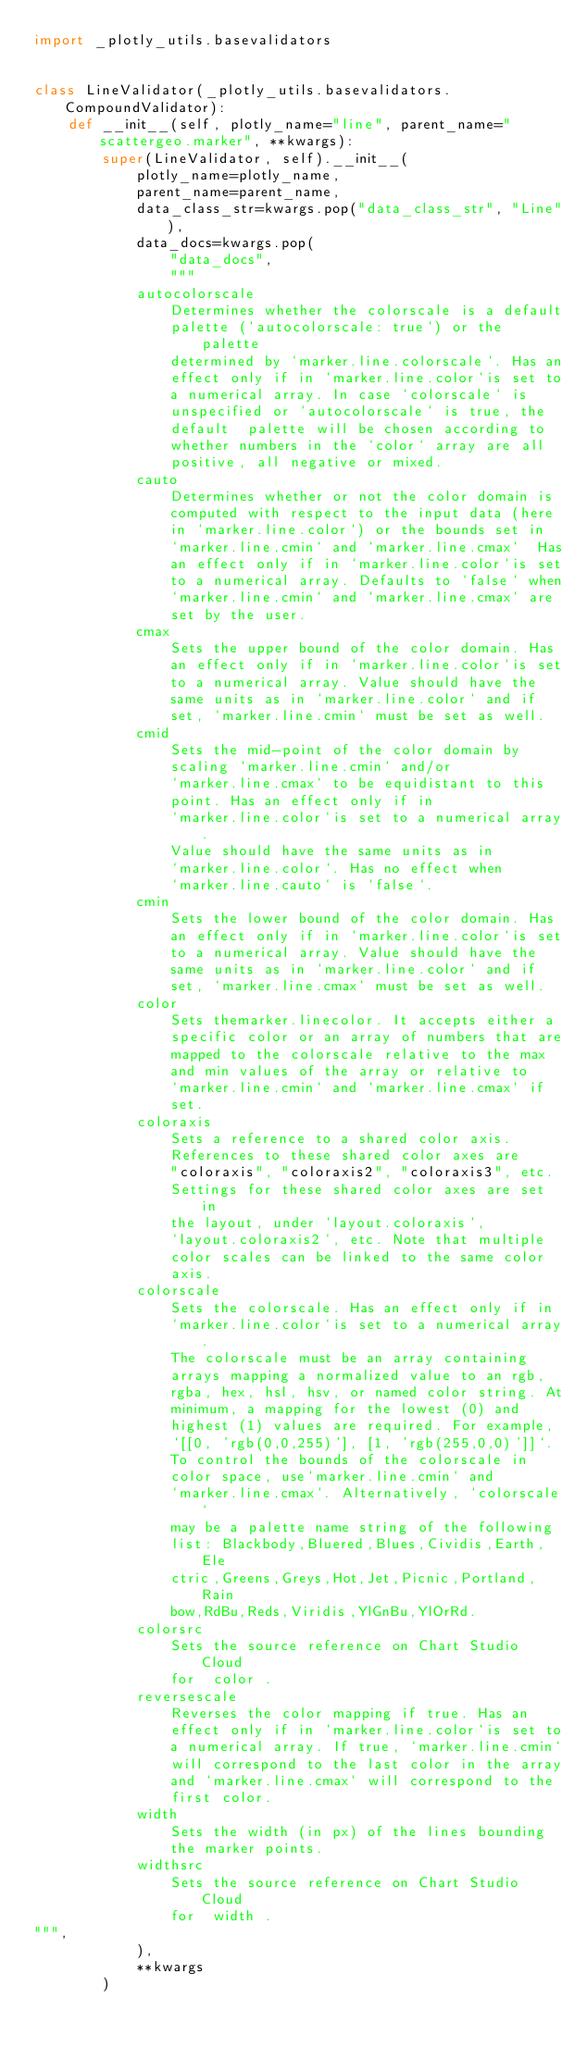Convert code to text. <code><loc_0><loc_0><loc_500><loc_500><_Python_>import _plotly_utils.basevalidators


class LineValidator(_plotly_utils.basevalidators.CompoundValidator):
    def __init__(self, plotly_name="line", parent_name="scattergeo.marker", **kwargs):
        super(LineValidator, self).__init__(
            plotly_name=plotly_name,
            parent_name=parent_name,
            data_class_str=kwargs.pop("data_class_str", "Line"),
            data_docs=kwargs.pop(
                "data_docs",
                """
            autocolorscale
                Determines whether the colorscale is a default
                palette (`autocolorscale: true`) or the palette
                determined by `marker.line.colorscale`. Has an
                effect only if in `marker.line.color`is set to
                a numerical array. In case `colorscale` is
                unspecified or `autocolorscale` is true, the
                default  palette will be chosen according to
                whether numbers in the `color` array are all
                positive, all negative or mixed.
            cauto
                Determines whether or not the color domain is
                computed with respect to the input data (here
                in `marker.line.color`) or the bounds set in
                `marker.line.cmin` and `marker.line.cmax`  Has
                an effect only if in `marker.line.color`is set
                to a numerical array. Defaults to `false` when
                `marker.line.cmin` and `marker.line.cmax` are
                set by the user.
            cmax
                Sets the upper bound of the color domain. Has
                an effect only if in `marker.line.color`is set
                to a numerical array. Value should have the
                same units as in `marker.line.color` and if
                set, `marker.line.cmin` must be set as well.
            cmid
                Sets the mid-point of the color domain by
                scaling `marker.line.cmin` and/or
                `marker.line.cmax` to be equidistant to this
                point. Has an effect only if in
                `marker.line.color`is set to a numerical array.
                Value should have the same units as in
                `marker.line.color`. Has no effect when
                `marker.line.cauto` is `false`.
            cmin
                Sets the lower bound of the color domain. Has
                an effect only if in `marker.line.color`is set
                to a numerical array. Value should have the
                same units as in `marker.line.color` and if
                set, `marker.line.cmax` must be set as well.
            color
                Sets themarker.linecolor. It accepts either a
                specific color or an array of numbers that are
                mapped to the colorscale relative to the max
                and min values of the array or relative to
                `marker.line.cmin` and `marker.line.cmax` if
                set.
            coloraxis
                Sets a reference to a shared color axis.
                References to these shared color axes are
                "coloraxis", "coloraxis2", "coloraxis3", etc.
                Settings for these shared color axes are set in
                the layout, under `layout.coloraxis`,
                `layout.coloraxis2`, etc. Note that multiple
                color scales can be linked to the same color
                axis.
            colorscale
                Sets the colorscale. Has an effect only if in
                `marker.line.color`is set to a numerical array.
                The colorscale must be an array containing
                arrays mapping a normalized value to an rgb,
                rgba, hex, hsl, hsv, or named color string. At
                minimum, a mapping for the lowest (0) and
                highest (1) values are required. For example,
                `[[0, 'rgb(0,0,255)'], [1, 'rgb(255,0,0)']]`.
                To control the bounds of the colorscale in
                color space, use`marker.line.cmin` and
                `marker.line.cmax`. Alternatively, `colorscale`
                may be a palette name string of the following
                list: Blackbody,Bluered,Blues,Cividis,Earth,Ele
                ctric,Greens,Greys,Hot,Jet,Picnic,Portland,Rain
                bow,RdBu,Reds,Viridis,YlGnBu,YlOrRd.
            colorsrc
                Sets the source reference on Chart Studio Cloud
                for  color .
            reversescale
                Reverses the color mapping if true. Has an
                effect only if in `marker.line.color`is set to
                a numerical array. If true, `marker.line.cmin`
                will correspond to the last color in the array
                and `marker.line.cmax` will correspond to the
                first color.
            width
                Sets the width (in px) of the lines bounding
                the marker points.
            widthsrc
                Sets the source reference on Chart Studio Cloud
                for  width .
""",
            ),
            **kwargs
        )
</code> 